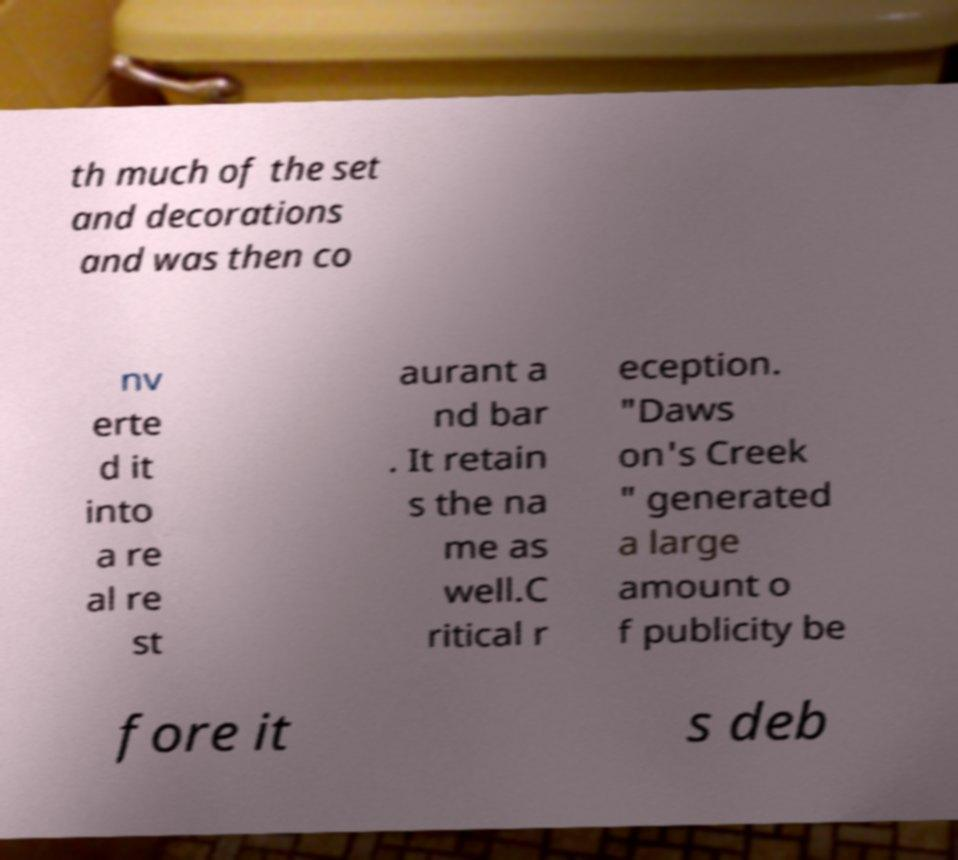There's text embedded in this image that I need extracted. Can you transcribe it verbatim? th much of the set and decorations and was then co nv erte d it into a re al re st aurant a nd bar . It retain s the na me as well.C ritical r eception. "Daws on's Creek " generated a large amount o f publicity be fore it s deb 